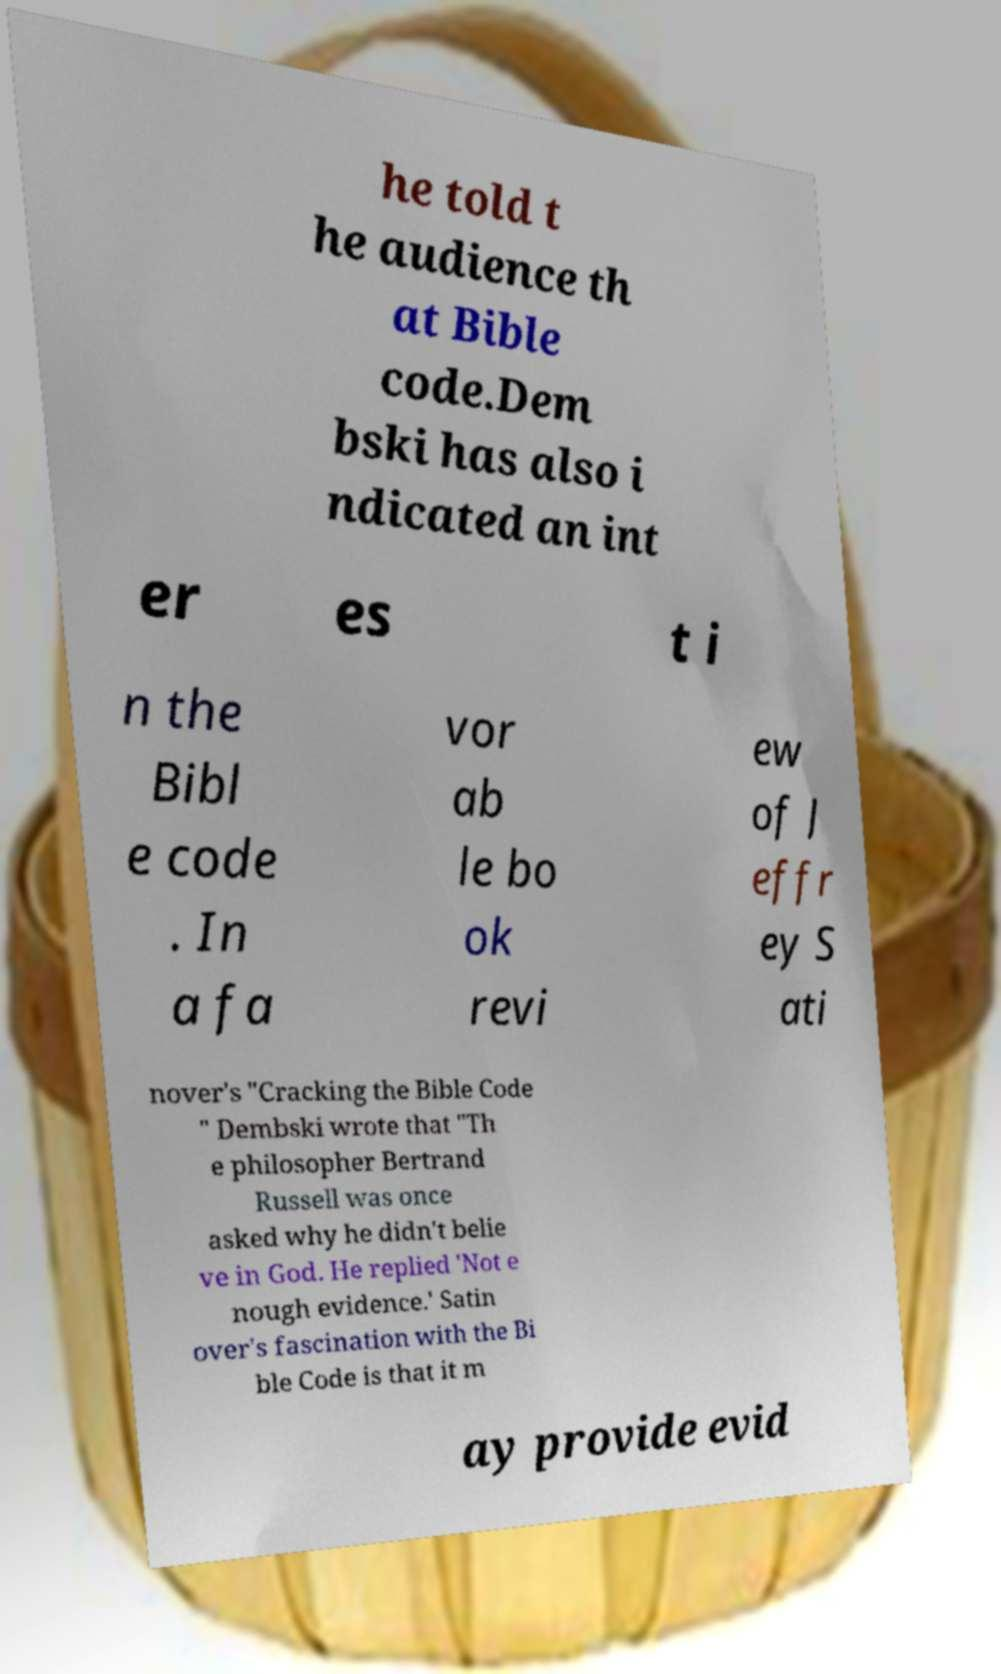Could you assist in decoding the text presented in this image and type it out clearly? he told t he audience th at Bible code.Dem bski has also i ndicated an int er es t i n the Bibl e code . In a fa vor ab le bo ok revi ew of J effr ey S ati nover's "Cracking the Bible Code " Dembski wrote that "Th e philosopher Bertrand Russell was once asked why he didn't belie ve in God. He replied 'Not e nough evidence.' Satin over's fascination with the Bi ble Code is that it m ay provide evid 